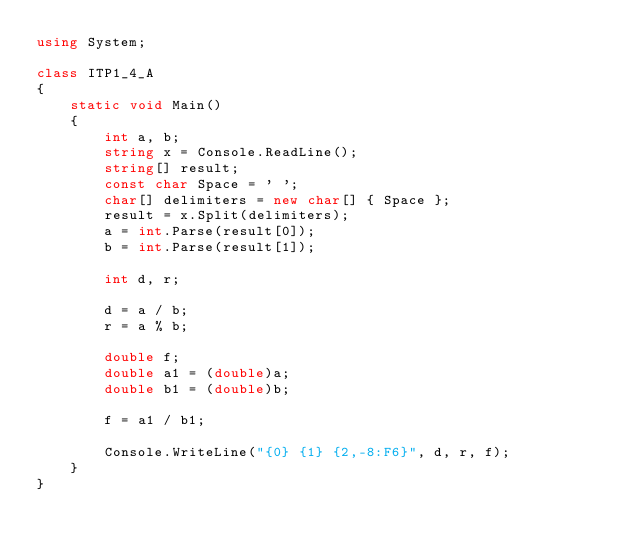Convert code to text. <code><loc_0><loc_0><loc_500><loc_500><_C#_>using System;

class ITP1_4_A
{
    static void Main()
    {
        int a, b;
        string x = Console.ReadLine();
        string[] result;
        const char Space = ' ';
        char[] delimiters = new char[] { Space };
        result = x.Split(delimiters);
        a = int.Parse(result[0]);
        b = int.Parse(result[1]);

        int d, r;

        d = a / b;
        r = a % b;

        double f;
        double a1 = (double)a;
        double b1 = (double)b;

        f = a1 / b1;

        Console.WriteLine("{0} {1} {2,-8:F6}", d, r, f);
    }
}
</code> 